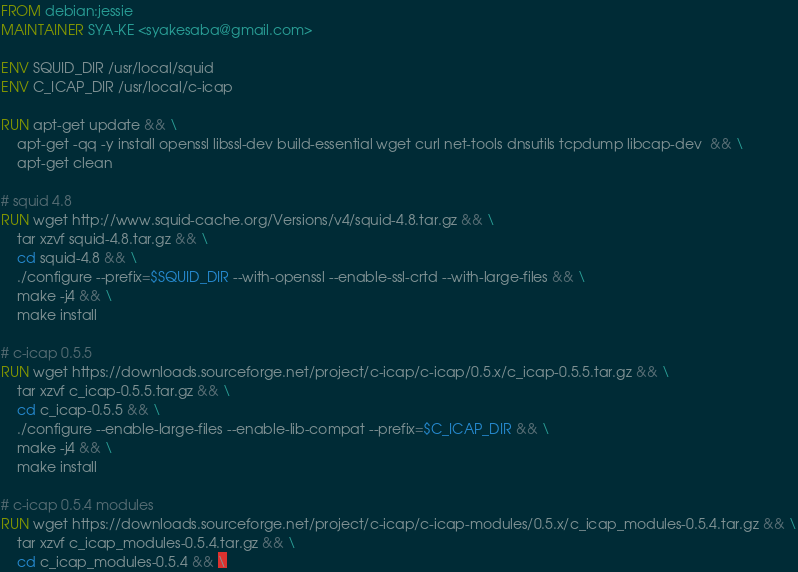Convert code to text. <code><loc_0><loc_0><loc_500><loc_500><_Dockerfile_>FROM debian:jessie
MAINTAINER SYA-KE <syakesaba@gmail.com>

ENV SQUID_DIR /usr/local/squid
ENV C_ICAP_DIR /usr/local/c-icap

RUN apt-get update && \
    apt-get -qq -y install openssl libssl-dev build-essential wget curl net-tools dnsutils tcpdump libcap-dev  && \
    apt-get clean

# squid 4.8
RUN wget http://www.squid-cache.org/Versions/v4/squid-4.8.tar.gz && \
    tar xzvf squid-4.8.tar.gz && \
    cd squid-4.8 && \
    ./configure --prefix=$SQUID_DIR --with-openssl --enable-ssl-crtd --with-large-files && \
    make -j4 && \
    make install

# c-icap 0.5.5
RUN wget https://downloads.sourceforge.net/project/c-icap/c-icap/0.5.x/c_icap-0.5.5.tar.gz && \
    tar xzvf c_icap-0.5.5.tar.gz && \
    cd c_icap-0.5.5 && \
    ./configure --enable-large-files --enable-lib-compat --prefix=$C_ICAP_DIR && \
    make -j4 && \
    make install

# c-icap 0.5.4 modules
RUN wget https://downloads.sourceforge.net/project/c-icap/c-icap-modules/0.5.x/c_icap_modules-0.5.4.tar.gz && \
    tar xzvf c_icap_modules-0.5.4.tar.gz && \
    cd c_icap_modules-0.5.4 && \</code> 